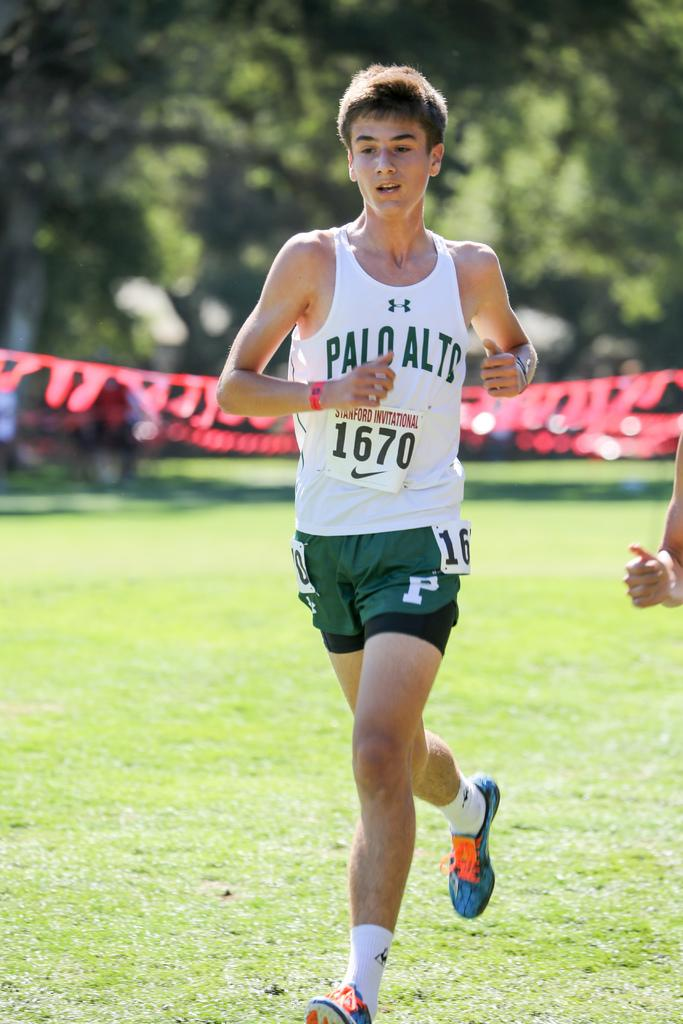<image>
Share a concise interpretation of the image provided. A young man is running on the track team from Palo Alto. 